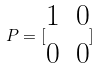<formula> <loc_0><loc_0><loc_500><loc_500>P = [ \begin{matrix} 1 & 0 \\ 0 & 0 \end{matrix} ]</formula> 